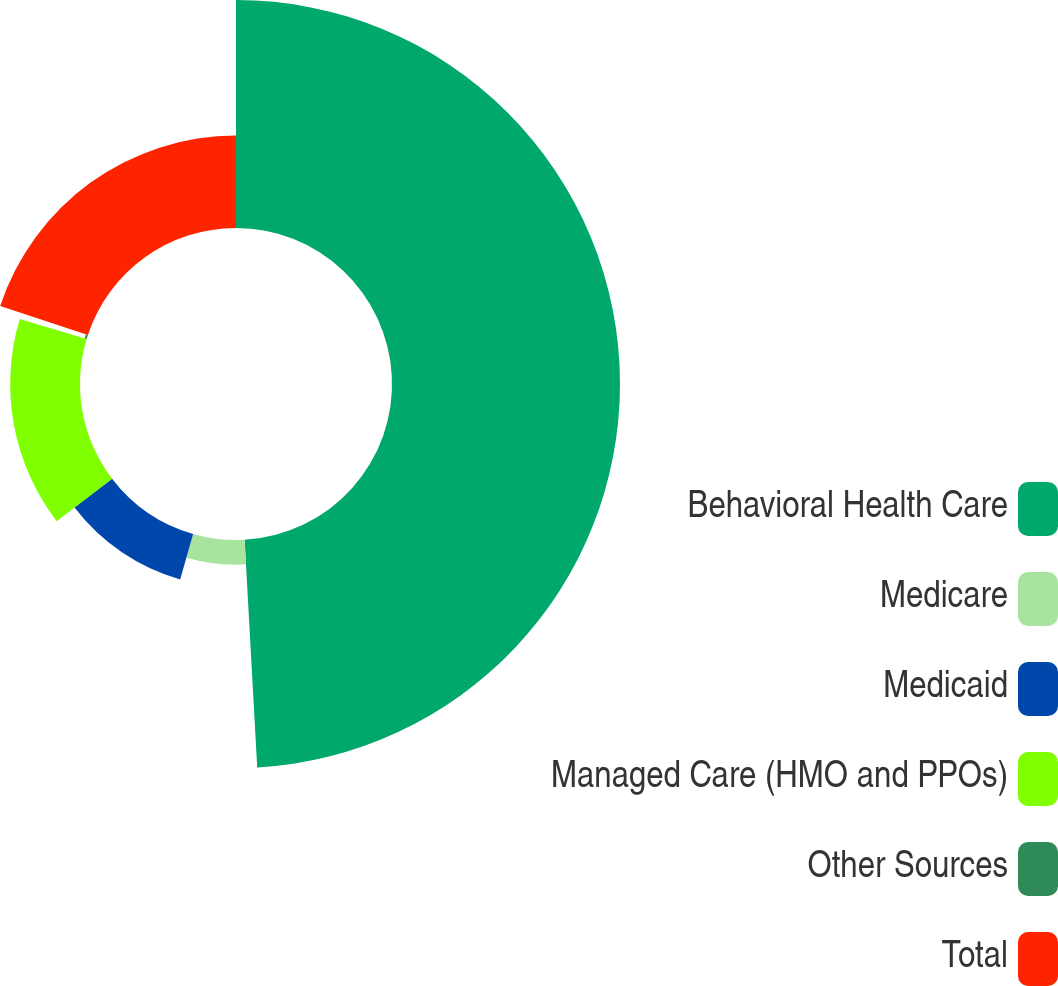Convert chart. <chart><loc_0><loc_0><loc_500><loc_500><pie_chart><fcel>Behavioral Health Care<fcel>Medicare<fcel>Medicaid<fcel>Managed Care (HMO and PPOs)<fcel>Other Sources<fcel>Total<nl><fcel>49.12%<fcel>5.31%<fcel>10.18%<fcel>15.04%<fcel>0.44%<fcel>19.91%<nl></chart> 